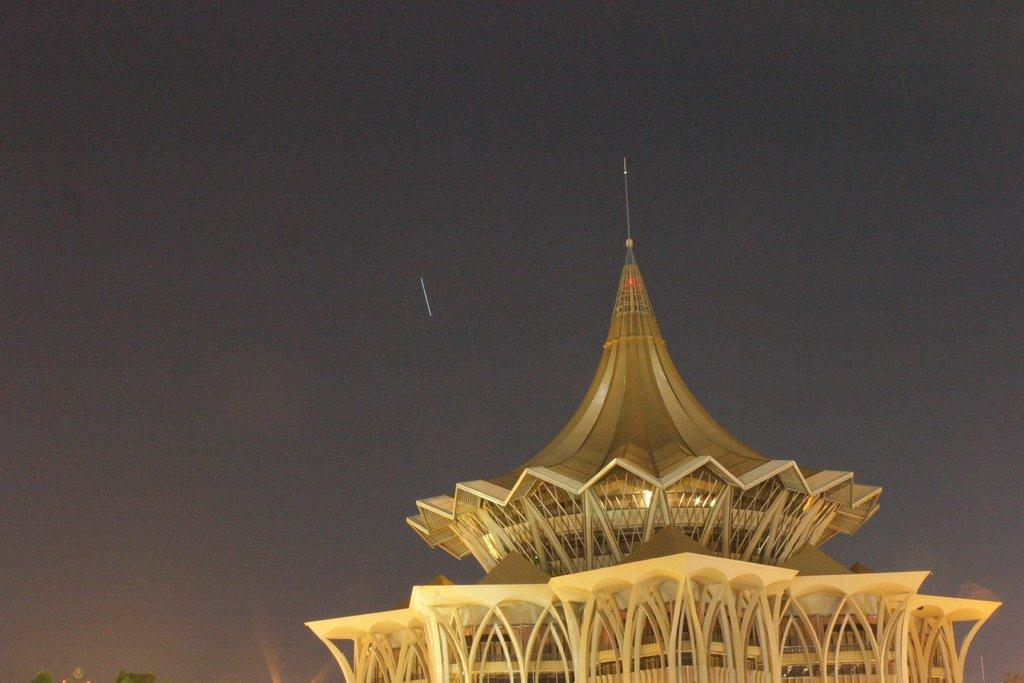Where was the image taken? The image was clicked outside. What is the main subject in the foreground of the image? There is a tower in the foreground of the image. What can be seen in the background of the image? There is a sky visible in the background of the image. What type of rhythm can be heard coming from the industry in the image? There is no industry present in the image, and therefore no rhythm can be heard. 